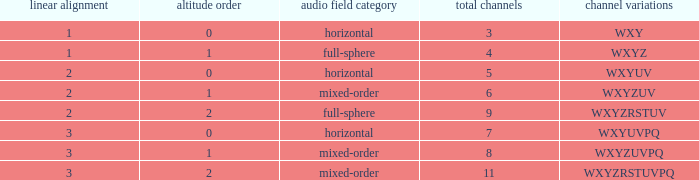If the channels is wxyzuv, what is the number of channels? 6.0. 